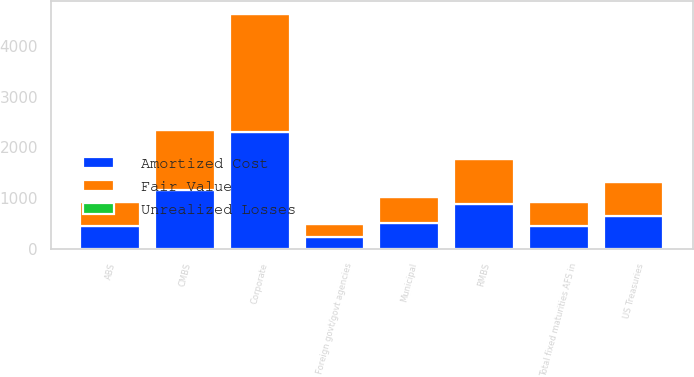Convert chart. <chart><loc_0><loc_0><loc_500><loc_500><stacked_bar_chart><ecel><fcel>ABS<fcel>CMBS<fcel>Corporate<fcel>Foreign govt/govt agencies<fcel>Municipal<fcel>RMBS<fcel>US Treasuries<fcel>Total fixed maturities AFS in<nl><fcel>Fair Value<fcel>461<fcel>1178<fcel>2322<fcel>244<fcel>511<fcel>889<fcel>658<fcel>460.5<nl><fcel>Amortized Cost<fcel>460<fcel>1167<fcel>2302<fcel>242<fcel>507<fcel>887<fcel>652<fcel>460.5<nl><fcel>Unrealized Losses<fcel>1<fcel>11<fcel>20<fcel>2<fcel>4<fcel>2<fcel>6<fcel>46<nl></chart> 